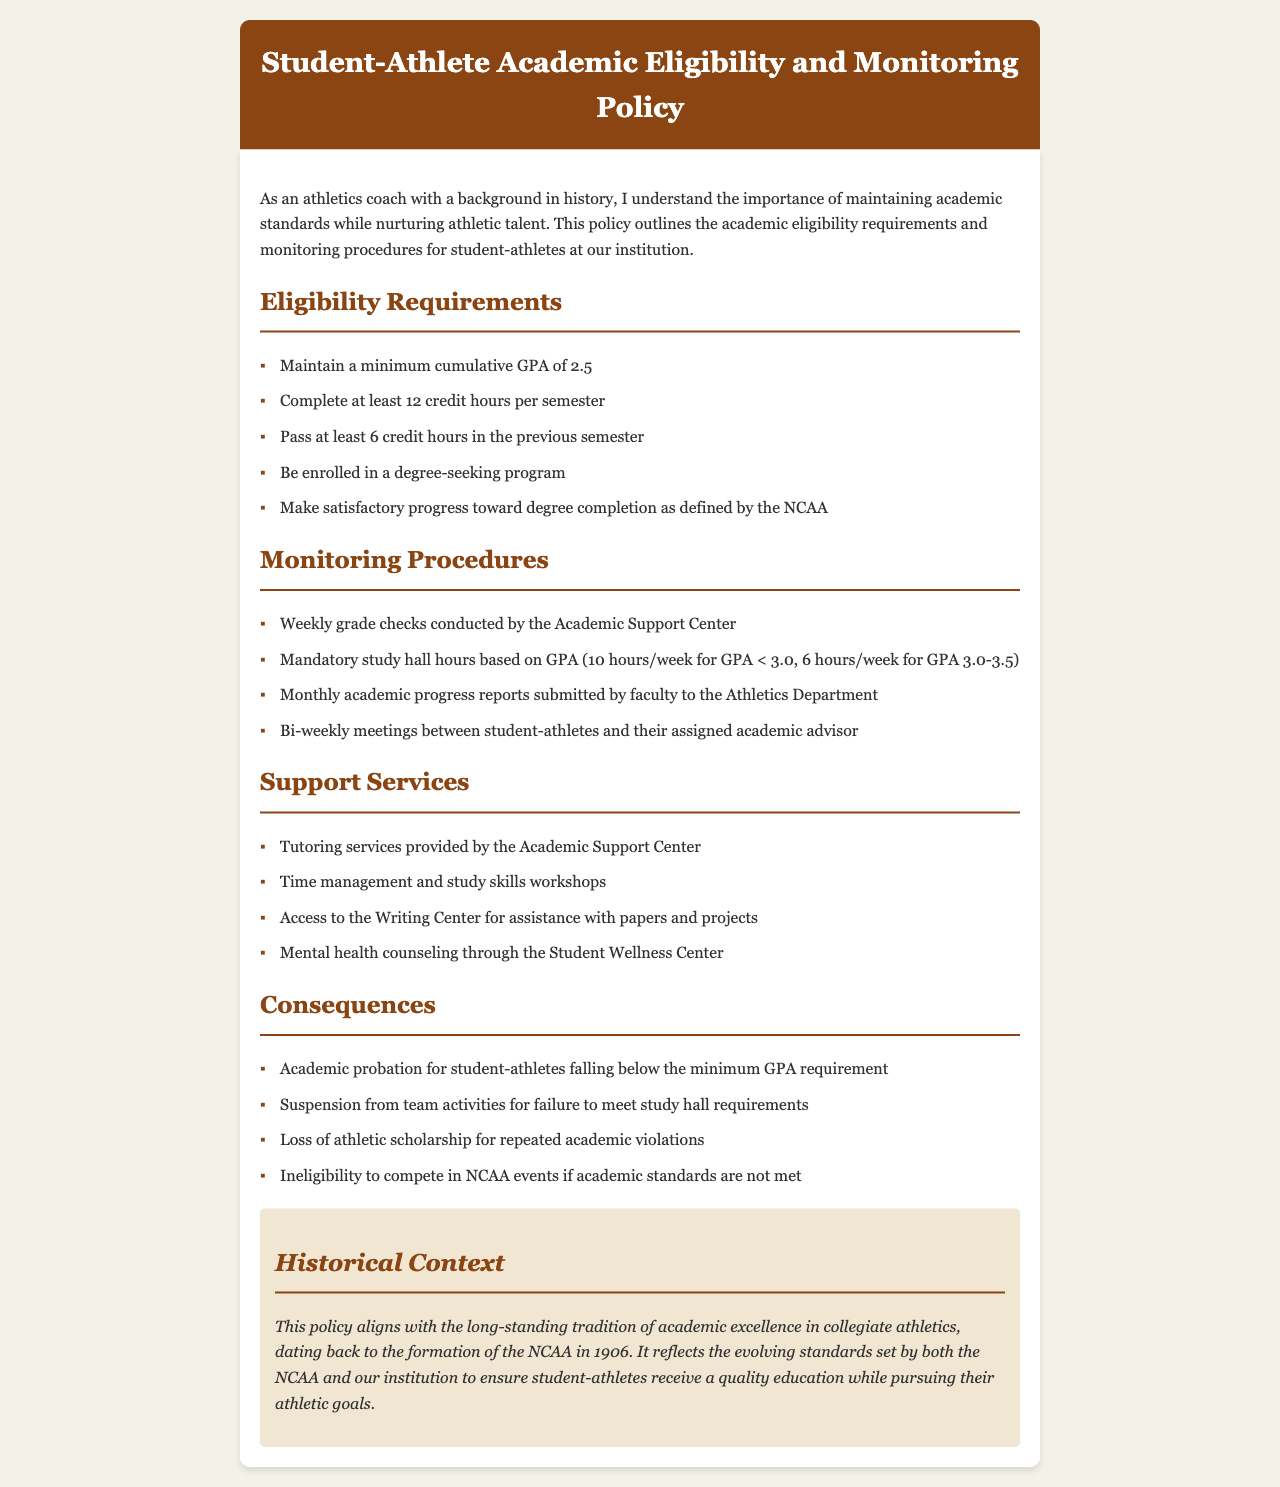What is the minimum cumulative GPA required for student-athletes? The minimum cumulative GPA requirement for student-athletes is specified in the eligibility requirements section.
Answer: 2.5 How many credit hours must a student-athlete complete per semester? This information can be found under the eligibility requirements section, indicating the minimum credit hours required.
Answer: 12 credit hours What is the consequence for falling below the minimum GPA requirement? The consequences section outlines specific penalties for academic performance, including this situation.
Answer: Academic probation How often are academic progress reports submitted by faculty? This detail regarding the frequency of reporting can be found in the monitoring procedures section.
Answer: Monthly What type of support service is offered for students needing help with papers? The support services section lists specific resources available to student-athletes.
Answer: Writing Center How many mandatory study hall hours are required for a GPA under 3.0? This information can be derived from the monitoring procedures regarding study hall requirements based on GPA.
Answer: 10 hours/week What action is taken for repeated academic violations? The list of consequences includes repercussions for failing to meet academic standards multiple times.
Answer: Loss of athletic scholarship What is the frequency of meetings between student-athletes and their academic advisor? The document specifies how often student-athletes meet with their advisors in the monitoring procedures section.
Answer: Bi-weekly In what year was the NCAA formed? The historical context section provides insight into the evolution of academic standards in collegiate athletics.
Answer: 1906 